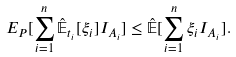<formula> <loc_0><loc_0><loc_500><loc_500>E _ { P } [ \sum _ { i = 1 } ^ { n } \hat { \mathbb { E } } _ { t _ { i } } [ \xi _ { i } ] I _ { A _ { i } } ] \leq \hat { \mathbb { E } } [ \sum _ { i = 1 } ^ { n } \xi _ { i } I _ { A _ { i } } ] .</formula> 